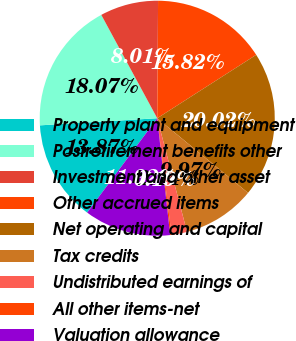Convert chart to OTSL. <chart><loc_0><loc_0><loc_500><loc_500><pie_chart><fcel>Property plant and equipment<fcel>Postretirement benefits other<fcel>Investment and other asset<fcel>Other accrued items<fcel>Net operating and capital<fcel>Tax credits<fcel>Undistributed earnings of<fcel>All other items-net<fcel>Valuation allowance<nl><fcel>13.87%<fcel>18.07%<fcel>8.01%<fcel>15.82%<fcel>20.02%<fcel>9.97%<fcel>2.14%<fcel>0.19%<fcel>11.92%<nl></chart> 